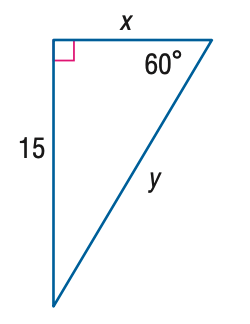Answer the mathemtical geometry problem and directly provide the correct option letter.
Question: Find y.
Choices: A: 5 \sqrt { 3 } B: 15 C: 10 \sqrt { 3 } D: 30 C 